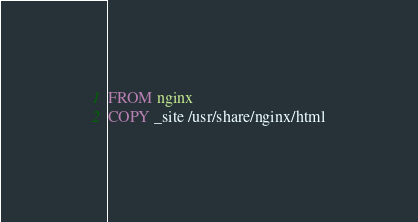Convert code to text. <code><loc_0><loc_0><loc_500><loc_500><_Dockerfile_>FROM nginx
COPY _site /usr/share/nginx/html
</code> 